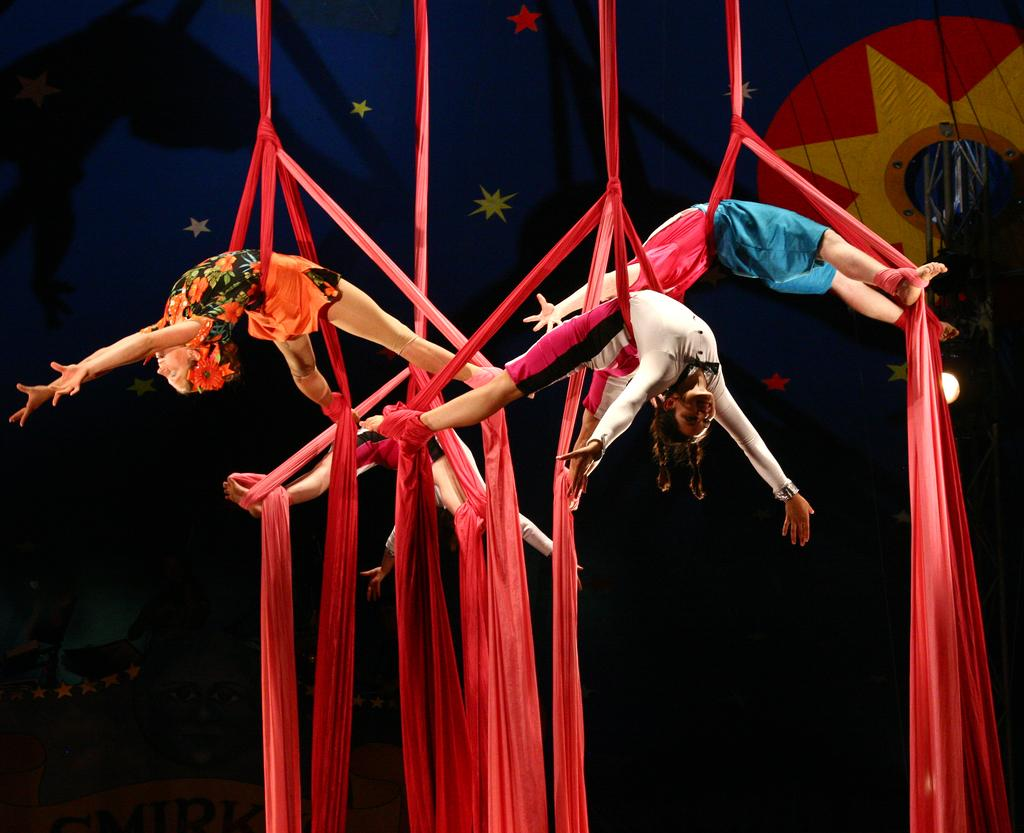How many people are in the trapeze position in the image? There are four persons in the trapeze position in the image. What are they using for support while in the trapeze position? They are using a red cloth for support. What can be seen in the background of the image? There is a designer curtain cloth with stars in the background. What type of lunch is being prepared by the carpenter in the image? There is no carpenter or lunch present in the image. What color are the crayons being used by the person in the trapeze position? There are no crayons visible in the image. 